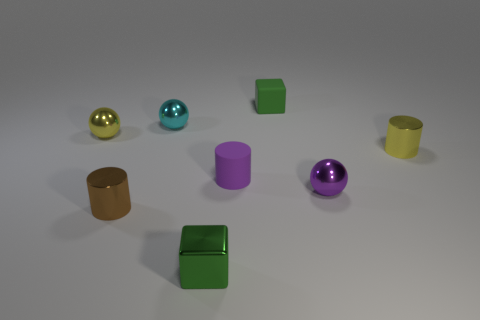What is the size of the thing that is the same color as the tiny metallic block?
Offer a terse response. Small. What is the material of the tiny thing that is the same color as the small metal block?
Offer a terse response. Rubber. Is the number of small purple things in front of the tiny matte cylinder greater than the number of tiny purple rubber cylinders to the right of the small yellow shiny cylinder?
Offer a very short reply. Yes. The green metallic object that is the same size as the rubber block is what shape?
Keep it short and to the point. Cube. What number of objects are purple metallic spheres or tiny objects on the right side of the cyan thing?
Ensure brevity in your answer.  5. Is the color of the metallic block the same as the small rubber cylinder?
Provide a short and direct response. No. What number of spheres are on the right side of the green shiny block?
Provide a short and direct response. 1. There is a cube that is made of the same material as the tiny brown cylinder; what is its color?
Your answer should be very brief. Green. What number of shiny objects are either tiny blocks or yellow objects?
Offer a terse response. 3. Does the tiny purple ball have the same material as the yellow cylinder?
Keep it short and to the point. Yes. 